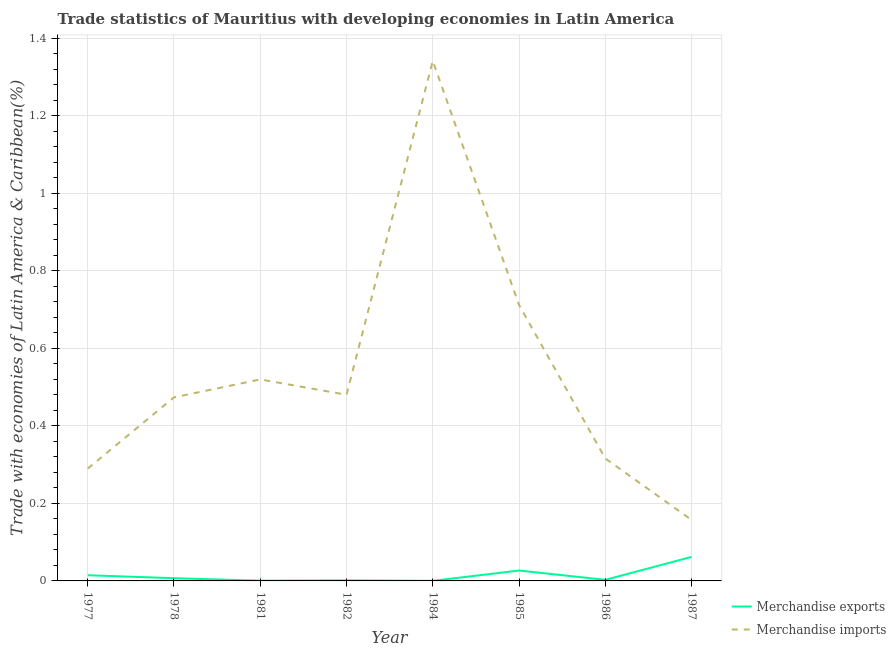Is the number of lines equal to the number of legend labels?
Your answer should be very brief. Yes. What is the merchandise exports in 1984?
Offer a very short reply. 0. Across all years, what is the maximum merchandise exports?
Give a very brief answer. 0.06. Across all years, what is the minimum merchandise exports?
Provide a short and direct response. 0. In which year was the merchandise exports maximum?
Provide a short and direct response. 1987. What is the total merchandise exports in the graph?
Your response must be concise. 0.12. What is the difference between the merchandise imports in 1982 and that in 1987?
Offer a very short reply. 0.32. What is the difference between the merchandise exports in 1982 and the merchandise imports in 1977?
Provide a succinct answer. -0.29. What is the average merchandise exports per year?
Offer a terse response. 0.01. In the year 1978, what is the difference between the merchandise exports and merchandise imports?
Keep it short and to the point. -0.47. In how many years, is the merchandise exports greater than 0.44 %?
Make the answer very short. 0. What is the ratio of the merchandise imports in 1982 to that in 1987?
Make the answer very short. 3.05. Is the difference between the merchandise imports in 1981 and 1985 greater than the difference between the merchandise exports in 1981 and 1985?
Offer a very short reply. No. What is the difference between the highest and the second highest merchandise exports?
Provide a short and direct response. 0.04. What is the difference between the highest and the lowest merchandise imports?
Your answer should be very brief. 1.18. In how many years, is the merchandise exports greater than the average merchandise exports taken over all years?
Ensure brevity in your answer.  3. Is the sum of the merchandise exports in 1981 and 1987 greater than the maximum merchandise imports across all years?
Make the answer very short. No. Does the merchandise exports monotonically increase over the years?
Provide a succinct answer. No. How many lines are there?
Give a very brief answer. 2. Does the graph contain any zero values?
Your answer should be very brief. No. Does the graph contain grids?
Ensure brevity in your answer.  Yes. How many legend labels are there?
Your response must be concise. 2. What is the title of the graph?
Make the answer very short. Trade statistics of Mauritius with developing economies in Latin America. Does "Broad money growth" appear as one of the legend labels in the graph?
Offer a very short reply. No. What is the label or title of the Y-axis?
Make the answer very short. Trade with economies of Latin America & Caribbean(%). What is the Trade with economies of Latin America & Caribbean(%) of Merchandise exports in 1977?
Give a very brief answer. 0.01. What is the Trade with economies of Latin America & Caribbean(%) of Merchandise imports in 1977?
Provide a short and direct response. 0.29. What is the Trade with economies of Latin America & Caribbean(%) of Merchandise exports in 1978?
Keep it short and to the point. 0.01. What is the Trade with economies of Latin America & Caribbean(%) of Merchandise imports in 1978?
Provide a short and direct response. 0.47. What is the Trade with economies of Latin America & Caribbean(%) in Merchandise exports in 1981?
Offer a terse response. 0. What is the Trade with economies of Latin America & Caribbean(%) of Merchandise imports in 1981?
Offer a terse response. 0.52. What is the Trade with economies of Latin America & Caribbean(%) in Merchandise exports in 1982?
Your answer should be compact. 0. What is the Trade with economies of Latin America & Caribbean(%) of Merchandise imports in 1982?
Give a very brief answer. 0.48. What is the Trade with economies of Latin America & Caribbean(%) in Merchandise exports in 1984?
Offer a very short reply. 0. What is the Trade with economies of Latin America & Caribbean(%) of Merchandise imports in 1984?
Your answer should be very brief. 1.34. What is the Trade with economies of Latin America & Caribbean(%) of Merchandise exports in 1985?
Offer a terse response. 0.03. What is the Trade with economies of Latin America & Caribbean(%) in Merchandise imports in 1985?
Provide a short and direct response. 0.71. What is the Trade with economies of Latin America & Caribbean(%) of Merchandise exports in 1986?
Provide a succinct answer. 0. What is the Trade with economies of Latin America & Caribbean(%) in Merchandise imports in 1986?
Your response must be concise. 0.32. What is the Trade with economies of Latin America & Caribbean(%) of Merchandise exports in 1987?
Give a very brief answer. 0.06. What is the Trade with economies of Latin America & Caribbean(%) of Merchandise imports in 1987?
Make the answer very short. 0.16. Across all years, what is the maximum Trade with economies of Latin America & Caribbean(%) of Merchandise exports?
Ensure brevity in your answer.  0.06. Across all years, what is the maximum Trade with economies of Latin America & Caribbean(%) in Merchandise imports?
Provide a succinct answer. 1.34. Across all years, what is the minimum Trade with economies of Latin America & Caribbean(%) of Merchandise exports?
Your response must be concise. 0. Across all years, what is the minimum Trade with economies of Latin America & Caribbean(%) in Merchandise imports?
Provide a short and direct response. 0.16. What is the total Trade with economies of Latin America & Caribbean(%) of Merchandise exports in the graph?
Keep it short and to the point. 0.12. What is the total Trade with economies of Latin America & Caribbean(%) in Merchandise imports in the graph?
Your answer should be compact. 4.29. What is the difference between the Trade with economies of Latin America & Caribbean(%) in Merchandise exports in 1977 and that in 1978?
Keep it short and to the point. 0.01. What is the difference between the Trade with economies of Latin America & Caribbean(%) in Merchandise imports in 1977 and that in 1978?
Provide a short and direct response. -0.18. What is the difference between the Trade with economies of Latin America & Caribbean(%) of Merchandise exports in 1977 and that in 1981?
Your answer should be very brief. 0.01. What is the difference between the Trade with economies of Latin America & Caribbean(%) in Merchandise imports in 1977 and that in 1981?
Offer a very short reply. -0.23. What is the difference between the Trade with economies of Latin America & Caribbean(%) of Merchandise exports in 1977 and that in 1982?
Ensure brevity in your answer.  0.01. What is the difference between the Trade with economies of Latin America & Caribbean(%) in Merchandise imports in 1977 and that in 1982?
Your answer should be very brief. -0.19. What is the difference between the Trade with economies of Latin America & Caribbean(%) in Merchandise exports in 1977 and that in 1984?
Keep it short and to the point. 0.01. What is the difference between the Trade with economies of Latin America & Caribbean(%) of Merchandise imports in 1977 and that in 1984?
Your answer should be very brief. -1.05. What is the difference between the Trade with economies of Latin America & Caribbean(%) in Merchandise exports in 1977 and that in 1985?
Keep it short and to the point. -0.01. What is the difference between the Trade with economies of Latin America & Caribbean(%) of Merchandise imports in 1977 and that in 1985?
Your response must be concise. -0.42. What is the difference between the Trade with economies of Latin America & Caribbean(%) of Merchandise exports in 1977 and that in 1986?
Offer a very short reply. 0.01. What is the difference between the Trade with economies of Latin America & Caribbean(%) in Merchandise imports in 1977 and that in 1986?
Keep it short and to the point. -0.03. What is the difference between the Trade with economies of Latin America & Caribbean(%) of Merchandise exports in 1977 and that in 1987?
Give a very brief answer. -0.05. What is the difference between the Trade with economies of Latin America & Caribbean(%) of Merchandise imports in 1977 and that in 1987?
Provide a succinct answer. 0.13. What is the difference between the Trade with economies of Latin America & Caribbean(%) in Merchandise exports in 1978 and that in 1981?
Ensure brevity in your answer.  0.01. What is the difference between the Trade with economies of Latin America & Caribbean(%) of Merchandise imports in 1978 and that in 1981?
Give a very brief answer. -0.05. What is the difference between the Trade with economies of Latin America & Caribbean(%) of Merchandise exports in 1978 and that in 1982?
Ensure brevity in your answer.  0.01. What is the difference between the Trade with economies of Latin America & Caribbean(%) in Merchandise imports in 1978 and that in 1982?
Offer a very short reply. -0.01. What is the difference between the Trade with economies of Latin America & Caribbean(%) of Merchandise exports in 1978 and that in 1984?
Offer a terse response. 0.01. What is the difference between the Trade with economies of Latin America & Caribbean(%) of Merchandise imports in 1978 and that in 1984?
Offer a terse response. -0.87. What is the difference between the Trade with economies of Latin America & Caribbean(%) in Merchandise exports in 1978 and that in 1985?
Keep it short and to the point. -0.02. What is the difference between the Trade with economies of Latin America & Caribbean(%) of Merchandise imports in 1978 and that in 1985?
Give a very brief answer. -0.24. What is the difference between the Trade with economies of Latin America & Caribbean(%) in Merchandise exports in 1978 and that in 1986?
Keep it short and to the point. 0. What is the difference between the Trade with economies of Latin America & Caribbean(%) of Merchandise imports in 1978 and that in 1986?
Your answer should be very brief. 0.16. What is the difference between the Trade with economies of Latin America & Caribbean(%) in Merchandise exports in 1978 and that in 1987?
Make the answer very short. -0.06. What is the difference between the Trade with economies of Latin America & Caribbean(%) in Merchandise imports in 1978 and that in 1987?
Provide a short and direct response. 0.32. What is the difference between the Trade with economies of Latin America & Caribbean(%) of Merchandise exports in 1981 and that in 1982?
Ensure brevity in your answer.  -0. What is the difference between the Trade with economies of Latin America & Caribbean(%) in Merchandise imports in 1981 and that in 1982?
Make the answer very short. 0.04. What is the difference between the Trade with economies of Latin America & Caribbean(%) of Merchandise imports in 1981 and that in 1984?
Keep it short and to the point. -0.82. What is the difference between the Trade with economies of Latin America & Caribbean(%) in Merchandise exports in 1981 and that in 1985?
Your answer should be compact. -0.03. What is the difference between the Trade with economies of Latin America & Caribbean(%) of Merchandise imports in 1981 and that in 1985?
Your answer should be compact. -0.19. What is the difference between the Trade with economies of Latin America & Caribbean(%) in Merchandise exports in 1981 and that in 1986?
Make the answer very short. -0. What is the difference between the Trade with economies of Latin America & Caribbean(%) of Merchandise imports in 1981 and that in 1986?
Keep it short and to the point. 0.2. What is the difference between the Trade with economies of Latin America & Caribbean(%) in Merchandise exports in 1981 and that in 1987?
Provide a succinct answer. -0.06. What is the difference between the Trade with economies of Latin America & Caribbean(%) in Merchandise imports in 1981 and that in 1987?
Provide a short and direct response. 0.36. What is the difference between the Trade with economies of Latin America & Caribbean(%) of Merchandise exports in 1982 and that in 1984?
Provide a succinct answer. 0. What is the difference between the Trade with economies of Latin America & Caribbean(%) of Merchandise imports in 1982 and that in 1984?
Make the answer very short. -0.86. What is the difference between the Trade with economies of Latin America & Caribbean(%) in Merchandise exports in 1982 and that in 1985?
Offer a very short reply. -0.03. What is the difference between the Trade with economies of Latin America & Caribbean(%) of Merchandise imports in 1982 and that in 1985?
Make the answer very short. -0.23. What is the difference between the Trade with economies of Latin America & Caribbean(%) of Merchandise exports in 1982 and that in 1986?
Your answer should be compact. -0. What is the difference between the Trade with economies of Latin America & Caribbean(%) of Merchandise imports in 1982 and that in 1986?
Keep it short and to the point. 0.16. What is the difference between the Trade with economies of Latin America & Caribbean(%) in Merchandise exports in 1982 and that in 1987?
Give a very brief answer. -0.06. What is the difference between the Trade with economies of Latin America & Caribbean(%) of Merchandise imports in 1982 and that in 1987?
Your answer should be very brief. 0.32. What is the difference between the Trade with economies of Latin America & Caribbean(%) of Merchandise exports in 1984 and that in 1985?
Ensure brevity in your answer.  -0.03. What is the difference between the Trade with economies of Latin America & Caribbean(%) of Merchandise imports in 1984 and that in 1985?
Your response must be concise. 0.63. What is the difference between the Trade with economies of Latin America & Caribbean(%) of Merchandise exports in 1984 and that in 1986?
Keep it short and to the point. -0. What is the difference between the Trade with economies of Latin America & Caribbean(%) in Merchandise imports in 1984 and that in 1986?
Your answer should be very brief. 1.03. What is the difference between the Trade with economies of Latin America & Caribbean(%) of Merchandise exports in 1984 and that in 1987?
Ensure brevity in your answer.  -0.06. What is the difference between the Trade with economies of Latin America & Caribbean(%) of Merchandise imports in 1984 and that in 1987?
Provide a short and direct response. 1.18. What is the difference between the Trade with economies of Latin America & Caribbean(%) in Merchandise exports in 1985 and that in 1986?
Keep it short and to the point. 0.02. What is the difference between the Trade with economies of Latin America & Caribbean(%) in Merchandise imports in 1985 and that in 1986?
Your answer should be very brief. 0.4. What is the difference between the Trade with economies of Latin America & Caribbean(%) in Merchandise exports in 1985 and that in 1987?
Keep it short and to the point. -0.04. What is the difference between the Trade with economies of Latin America & Caribbean(%) in Merchandise imports in 1985 and that in 1987?
Provide a short and direct response. 0.55. What is the difference between the Trade with economies of Latin America & Caribbean(%) of Merchandise exports in 1986 and that in 1987?
Ensure brevity in your answer.  -0.06. What is the difference between the Trade with economies of Latin America & Caribbean(%) of Merchandise imports in 1986 and that in 1987?
Ensure brevity in your answer.  0.16. What is the difference between the Trade with economies of Latin America & Caribbean(%) in Merchandise exports in 1977 and the Trade with economies of Latin America & Caribbean(%) in Merchandise imports in 1978?
Give a very brief answer. -0.46. What is the difference between the Trade with economies of Latin America & Caribbean(%) in Merchandise exports in 1977 and the Trade with economies of Latin America & Caribbean(%) in Merchandise imports in 1981?
Ensure brevity in your answer.  -0.51. What is the difference between the Trade with economies of Latin America & Caribbean(%) of Merchandise exports in 1977 and the Trade with economies of Latin America & Caribbean(%) of Merchandise imports in 1982?
Provide a succinct answer. -0.47. What is the difference between the Trade with economies of Latin America & Caribbean(%) in Merchandise exports in 1977 and the Trade with economies of Latin America & Caribbean(%) in Merchandise imports in 1984?
Keep it short and to the point. -1.33. What is the difference between the Trade with economies of Latin America & Caribbean(%) in Merchandise exports in 1977 and the Trade with economies of Latin America & Caribbean(%) in Merchandise imports in 1985?
Keep it short and to the point. -0.7. What is the difference between the Trade with economies of Latin America & Caribbean(%) of Merchandise exports in 1977 and the Trade with economies of Latin America & Caribbean(%) of Merchandise imports in 1986?
Make the answer very short. -0.3. What is the difference between the Trade with economies of Latin America & Caribbean(%) in Merchandise exports in 1977 and the Trade with economies of Latin America & Caribbean(%) in Merchandise imports in 1987?
Give a very brief answer. -0.14. What is the difference between the Trade with economies of Latin America & Caribbean(%) of Merchandise exports in 1978 and the Trade with economies of Latin America & Caribbean(%) of Merchandise imports in 1981?
Offer a very short reply. -0.51. What is the difference between the Trade with economies of Latin America & Caribbean(%) in Merchandise exports in 1978 and the Trade with economies of Latin America & Caribbean(%) in Merchandise imports in 1982?
Your response must be concise. -0.47. What is the difference between the Trade with economies of Latin America & Caribbean(%) in Merchandise exports in 1978 and the Trade with economies of Latin America & Caribbean(%) in Merchandise imports in 1984?
Your answer should be compact. -1.34. What is the difference between the Trade with economies of Latin America & Caribbean(%) in Merchandise exports in 1978 and the Trade with economies of Latin America & Caribbean(%) in Merchandise imports in 1985?
Your answer should be very brief. -0.71. What is the difference between the Trade with economies of Latin America & Caribbean(%) of Merchandise exports in 1978 and the Trade with economies of Latin America & Caribbean(%) of Merchandise imports in 1986?
Provide a short and direct response. -0.31. What is the difference between the Trade with economies of Latin America & Caribbean(%) of Merchandise exports in 1978 and the Trade with economies of Latin America & Caribbean(%) of Merchandise imports in 1987?
Your answer should be compact. -0.15. What is the difference between the Trade with economies of Latin America & Caribbean(%) of Merchandise exports in 1981 and the Trade with economies of Latin America & Caribbean(%) of Merchandise imports in 1982?
Your answer should be very brief. -0.48. What is the difference between the Trade with economies of Latin America & Caribbean(%) of Merchandise exports in 1981 and the Trade with economies of Latin America & Caribbean(%) of Merchandise imports in 1984?
Ensure brevity in your answer.  -1.34. What is the difference between the Trade with economies of Latin America & Caribbean(%) in Merchandise exports in 1981 and the Trade with economies of Latin America & Caribbean(%) in Merchandise imports in 1985?
Offer a very short reply. -0.71. What is the difference between the Trade with economies of Latin America & Caribbean(%) of Merchandise exports in 1981 and the Trade with economies of Latin America & Caribbean(%) of Merchandise imports in 1986?
Your response must be concise. -0.32. What is the difference between the Trade with economies of Latin America & Caribbean(%) in Merchandise exports in 1981 and the Trade with economies of Latin America & Caribbean(%) in Merchandise imports in 1987?
Your answer should be compact. -0.16. What is the difference between the Trade with economies of Latin America & Caribbean(%) in Merchandise exports in 1982 and the Trade with economies of Latin America & Caribbean(%) in Merchandise imports in 1984?
Offer a very short reply. -1.34. What is the difference between the Trade with economies of Latin America & Caribbean(%) in Merchandise exports in 1982 and the Trade with economies of Latin America & Caribbean(%) in Merchandise imports in 1985?
Keep it short and to the point. -0.71. What is the difference between the Trade with economies of Latin America & Caribbean(%) in Merchandise exports in 1982 and the Trade with economies of Latin America & Caribbean(%) in Merchandise imports in 1986?
Provide a succinct answer. -0.31. What is the difference between the Trade with economies of Latin America & Caribbean(%) in Merchandise exports in 1982 and the Trade with economies of Latin America & Caribbean(%) in Merchandise imports in 1987?
Keep it short and to the point. -0.16. What is the difference between the Trade with economies of Latin America & Caribbean(%) of Merchandise exports in 1984 and the Trade with economies of Latin America & Caribbean(%) of Merchandise imports in 1985?
Offer a terse response. -0.71. What is the difference between the Trade with economies of Latin America & Caribbean(%) in Merchandise exports in 1984 and the Trade with economies of Latin America & Caribbean(%) in Merchandise imports in 1986?
Give a very brief answer. -0.32. What is the difference between the Trade with economies of Latin America & Caribbean(%) of Merchandise exports in 1984 and the Trade with economies of Latin America & Caribbean(%) of Merchandise imports in 1987?
Your answer should be very brief. -0.16. What is the difference between the Trade with economies of Latin America & Caribbean(%) of Merchandise exports in 1985 and the Trade with economies of Latin America & Caribbean(%) of Merchandise imports in 1986?
Provide a short and direct response. -0.29. What is the difference between the Trade with economies of Latin America & Caribbean(%) of Merchandise exports in 1985 and the Trade with economies of Latin America & Caribbean(%) of Merchandise imports in 1987?
Keep it short and to the point. -0.13. What is the difference between the Trade with economies of Latin America & Caribbean(%) of Merchandise exports in 1986 and the Trade with economies of Latin America & Caribbean(%) of Merchandise imports in 1987?
Offer a very short reply. -0.15. What is the average Trade with economies of Latin America & Caribbean(%) of Merchandise exports per year?
Ensure brevity in your answer.  0.01. What is the average Trade with economies of Latin America & Caribbean(%) in Merchandise imports per year?
Ensure brevity in your answer.  0.54. In the year 1977, what is the difference between the Trade with economies of Latin America & Caribbean(%) of Merchandise exports and Trade with economies of Latin America & Caribbean(%) of Merchandise imports?
Ensure brevity in your answer.  -0.28. In the year 1978, what is the difference between the Trade with economies of Latin America & Caribbean(%) of Merchandise exports and Trade with economies of Latin America & Caribbean(%) of Merchandise imports?
Offer a terse response. -0.47. In the year 1981, what is the difference between the Trade with economies of Latin America & Caribbean(%) of Merchandise exports and Trade with economies of Latin America & Caribbean(%) of Merchandise imports?
Your answer should be very brief. -0.52. In the year 1982, what is the difference between the Trade with economies of Latin America & Caribbean(%) in Merchandise exports and Trade with economies of Latin America & Caribbean(%) in Merchandise imports?
Your answer should be compact. -0.48. In the year 1984, what is the difference between the Trade with economies of Latin America & Caribbean(%) of Merchandise exports and Trade with economies of Latin America & Caribbean(%) of Merchandise imports?
Your answer should be compact. -1.34. In the year 1985, what is the difference between the Trade with economies of Latin America & Caribbean(%) of Merchandise exports and Trade with economies of Latin America & Caribbean(%) of Merchandise imports?
Your answer should be compact. -0.69. In the year 1986, what is the difference between the Trade with economies of Latin America & Caribbean(%) of Merchandise exports and Trade with economies of Latin America & Caribbean(%) of Merchandise imports?
Your response must be concise. -0.31. In the year 1987, what is the difference between the Trade with economies of Latin America & Caribbean(%) in Merchandise exports and Trade with economies of Latin America & Caribbean(%) in Merchandise imports?
Make the answer very short. -0.1. What is the ratio of the Trade with economies of Latin America & Caribbean(%) of Merchandise exports in 1977 to that in 1978?
Keep it short and to the point. 2.1. What is the ratio of the Trade with economies of Latin America & Caribbean(%) in Merchandise imports in 1977 to that in 1978?
Give a very brief answer. 0.61. What is the ratio of the Trade with economies of Latin America & Caribbean(%) of Merchandise exports in 1977 to that in 1981?
Provide a succinct answer. 23.31. What is the ratio of the Trade with economies of Latin America & Caribbean(%) in Merchandise imports in 1977 to that in 1981?
Provide a short and direct response. 0.56. What is the ratio of the Trade with economies of Latin America & Caribbean(%) of Merchandise exports in 1977 to that in 1982?
Offer a terse response. 10.54. What is the ratio of the Trade with economies of Latin America & Caribbean(%) of Merchandise imports in 1977 to that in 1982?
Give a very brief answer. 0.6. What is the ratio of the Trade with economies of Latin America & Caribbean(%) of Merchandise exports in 1977 to that in 1984?
Offer a terse response. 53.76. What is the ratio of the Trade with economies of Latin America & Caribbean(%) of Merchandise imports in 1977 to that in 1984?
Your answer should be very brief. 0.22. What is the ratio of the Trade with economies of Latin America & Caribbean(%) of Merchandise exports in 1977 to that in 1985?
Give a very brief answer. 0.55. What is the ratio of the Trade with economies of Latin America & Caribbean(%) in Merchandise imports in 1977 to that in 1985?
Keep it short and to the point. 0.41. What is the ratio of the Trade with economies of Latin America & Caribbean(%) of Merchandise exports in 1977 to that in 1986?
Provide a short and direct response. 5.27. What is the ratio of the Trade with economies of Latin America & Caribbean(%) of Merchandise imports in 1977 to that in 1986?
Keep it short and to the point. 0.92. What is the ratio of the Trade with economies of Latin America & Caribbean(%) of Merchandise exports in 1977 to that in 1987?
Your answer should be compact. 0.24. What is the ratio of the Trade with economies of Latin America & Caribbean(%) of Merchandise imports in 1977 to that in 1987?
Offer a terse response. 1.84. What is the ratio of the Trade with economies of Latin America & Caribbean(%) of Merchandise exports in 1978 to that in 1981?
Offer a very short reply. 11.1. What is the ratio of the Trade with economies of Latin America & Caribbean(%) of Merchandise imports in 1978 to that in 1981?
Keep it short and to the point. 0.91. What is the ratio of the Trade with economies of Latin America & Caribbean(%) in Merchandise exports in 1978 to that in 1982?
Offer a terse response. 5.02. What is the ratio of the Trade with economies of Latin America & Caribbean(%) in Merchandise imports in 1978 to that in 1982?
Make the answer very short. 0.99. What is the ratio of the Trade with economies of Latin America & Caribbean(%) of Merchandise exports in 1978 to that in 1984?
Your answer should be very brief. 25.59. What is the ratio of the Trade with economies of Latin America & Caribbean(%) in Merchandise imports in 1978 to that in 1984?
Provide a short and direct response. 0.35. What is the ratio of the Trade with economies of Latin America & Caribbean(%) in Merchandise exports in 1978 to that in 1985?
Make the answer very short. 0.26. What is the ratio of the Trade with economies of Latin America & Caribbean(%) in Merchandise imports in 1978 to that in 1985?
Your answer should be very brief. 0.67. What is the ratio of the Trade with economies of Latin America & Caribbean(%) in Merchandise exports in 1978 to that in 1986?
Offer a terse response. 2.51. What is the ratio of the Trade with economies of Latin America & Caribbean(%) of Merchandise imports in 1978 to that in 1986?
Your answer should be compact. 1.5. What is the ratio of the Trade with economies of Latin America & Caribbean(%) in Merchandise exports in 1978 to that in 1987?
Make the answer very short. 0.11. What is the ratio of the Trade with economies of Latin America & Caribbean(%) of Merchandise imports in 1978 to that in 1987?
Your answer should be compact. 3.01. What is the ratio of the Trade with economies of Latin America & Caribbean(%) in Merchandise exports in 1981 to that in 1982?
Give a very brief answer. 0.45. What is the ratio of the Trade with economies of Latin America & Caribbean(%) of Merchandise imports in 1981 to that in 1982?
Make the answer very short. 1.08. What is the ratio of the Trade with economies of Latin America & Caribbean(%) of Merchandise exports in 1981 to that in 1984?
Provide a succinct answer. 2.31. What is the ratio of the Trade with economies of Latin America & Caribbean(%) of Merchandise imports in 1981 to that in 1984?
Ensure brevity in your answer.  0.39. What is the ratio of the Trade with economies of Latin America & Caribbean(%) of Merchandise exports in 1981 to that in 1985?
Give a very brief answer. 0.02. What is the ratio of the Trade with economies of Latin America & Caribbean(%) in Merchandise imports in 1981 to that in 1985?
Your answer should be compact. 0.73. What is the ratio of the Trade with economies of Latin America & Caribbean(%) in Merchandise exports in 1981 to that in 1986?
Provide a succinct answer. 0.23. What is the ratio of the Trade with economies of Latin America & Caribbean(%) in Merchandise imports in 1981 to that in 1986?
Give a very brief answer. 1.65. What is the ratio of the Trade with economies of Latin America & Caribbean(%) of Merchandise exports in 1981 to that in 1987?
Offer a terse response. 0.01. What is the ratio of the Trade with economies of Latin America & Caribbean(%) in Merchandise imports in 1981 to that in 1987?
Provide a short and direct response. 3.3. What is the ratio of the Trade with economies of Latin America & Caribbean(%) of Merchandise exports in 1982 to that in 1984?
Ensure brevity in your answer.  5.1. What is the ratio of the Trade with economies of Latin America & Caribbean(%) in Merchandise imports in 1982 to that in 1984?
Your answer should be compact. 0.36. What is the ratio of the Trade with economies of Latin America & Caribbean(%) of Merchandise exports in 1982 to that in 1985?
Ensure brevity in your answer.  0.05. What is the ratio of the Trade with economies of Latin America & Caribbean(%) of Merchandise imports in 1982 to that in 1985?
Your answer should be compact. 0.67. What is the ratio of the Trade with economies of Latin America & Caribbean(%) in Merchandise exports in 1982 to that in 1986?
Provide a succinct answer. 0.5. What is the ratio of the Trade with economies of Latin America & Caribbean(%) in Merchandise imports in 1982 to that in 1986?
Offer a very short reply. 1.52. What is the ratio of the Trade with economies of Latin America & Caribbean(%) in Merchandise exports in 1982 to that in 1987?
Your answer should be compact. 0.02. What is the ratio of the Trade with economies of Latin America & Caribbean(%) in Merchandise imports in 1982 to that in 1987?
Your answer should be very brief. 3.05. What is the ratio of the Trade with economies of Latin America & Caribbean(%) of Merchandise exports in 1984 to that in 1985?
Make the answer very short. 0.01. What is the ratio of the Trade with economies of Latin America & Caribbean(%) in Merchandise imports in 1984 to that in 1985?
Your answer should be very brief. 1.88. What is the ratio of the Trade with economies of Latin America & Caribbean(%) in Merchandise exports in 1984 to that in 1986?
Make the answer very short. 0.1. What is the ratio of the Trade with economies of Latin America & Caribbean(%) of Merchandise imports in 1984 to that in 1986?
Offer a very short reply. 4.25. What is the ratio of the Trade with economies of Latin America & Caribbean(%) of Merchandise exports in 1984 to that in 1987?
Provide a succinct answer. 0. What is the ratio of the Trade with economies of Latin America & Caribbean(%) in Merchandise imports in 1984 to that in 1987?
Provide a short and direct response. 8.52. What is the ratio of the Trade with economies of Latin America & Caribbean(%) in Merchandise exports in 1985 to that in 1986?
Provide a succinct answer. 9.62. What is the ratio of the Trade with economies of Latin America & Caribbean(%) of Merchandise imports in 1985 to that in 1986?
Make the answer very short. 2.25. What is the ratio of the Trade with economies of Latin America & Caribbean(%) in Merchandise exports in 1985 to that in 1987?
Offer a very short reply. 0.43. What is the ratio of the Trade with economies of Latin America & Caribbean(%) of Merchandise imports in 1985 to that in 1987?
Make the answer very short. 4.52. What is the ratio of the Trade with economies of Latin America & Caribbean(%) of Merchandise exports in 1986 to that in 1987?
Offer a very short reply. 0.04. What is the ratio of the Trade with economies of Latin America & Caribbean(%) in Merchandise imports in 1986 to that in 1987?
Your response must be concise. 2.01. What is the difference between the highest and the second highest Trade with economies of Latin America & Caribbean(%) of Merchandise exports?
Your response must be concise. 0.04. What is the difference between the highest and the second highest Trade with economies of Latin America & Caribbean(%) of Merchandise imports?
Give a very brief answer. 0.63. What is the difference between the highest and the lowest Trade with economies of Latin America & Caribbean(%) of Merchandise exports?
Offer a very short reply. 0.06. What is the difference between the highest and the lowest Trade with economies of Latin America & Caribbean(%) in Merchandise imports?
Offer a terse response. 1.18. 